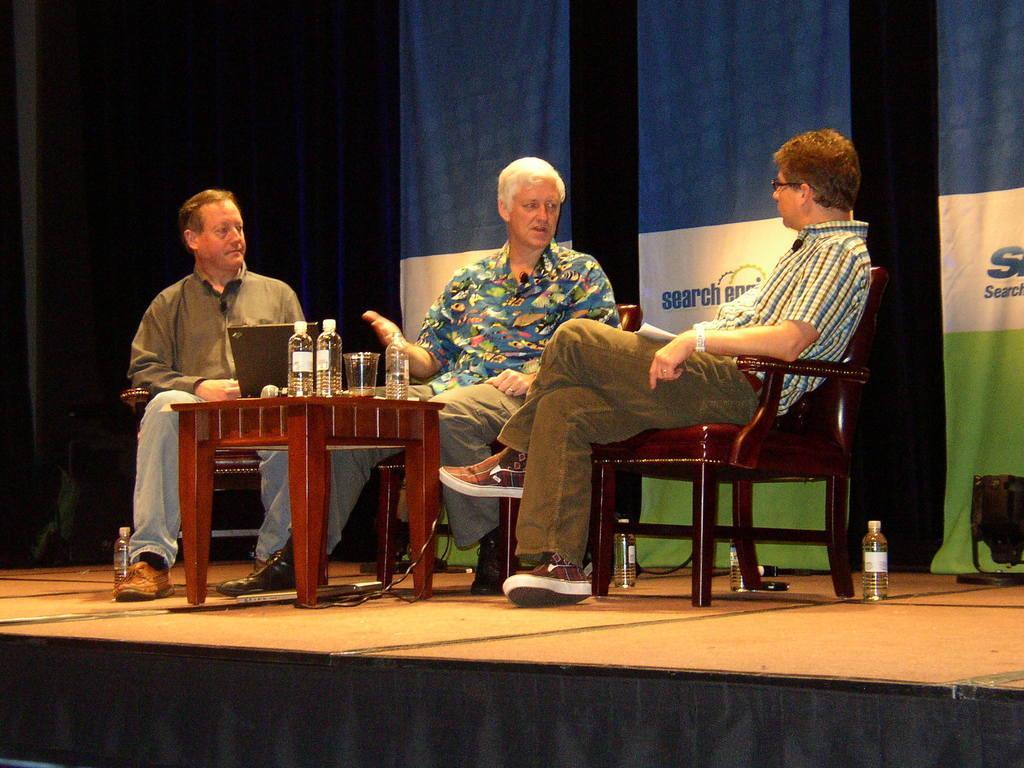Describe this image in one or two sentences. The person in the middle is sitting in a chair and speaking in front of a person sitting beside him and there is other person sitting on the other side of him and there is a table in front of them which has water bottles and laptop on it. 